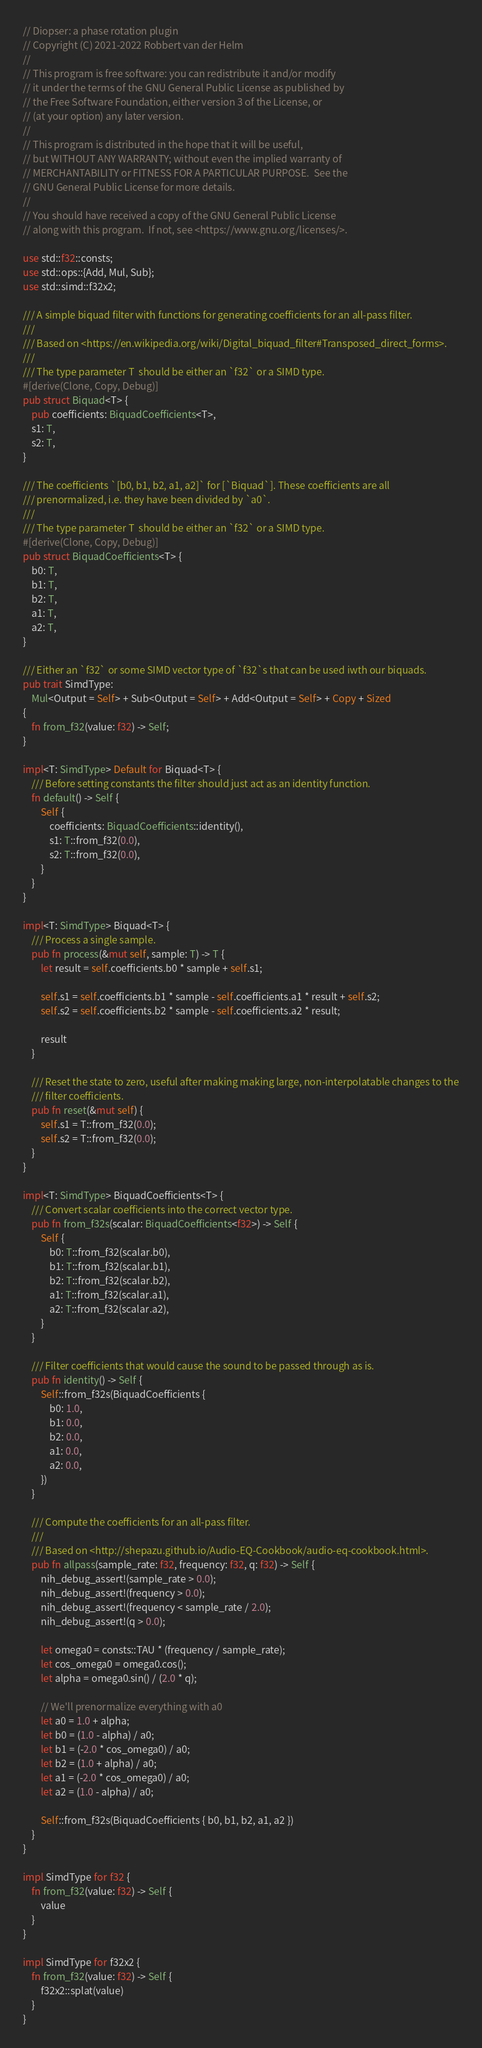<code> <loc_0><loc_0><loc_500><loc_500><_Rust_>// Diopser: a phase rotation plugin
// Copyright (C) 2021-2022 Robbert van der Helm
//
// This program is free software: you can redistribute it and/or modify
// it under the terms of the GNU General Public License as published by
// the Free Software Foundation, either version 3 of the License, or
// (at your option) any later version.
//
// This program is distributed in the hope that it will be useful,
// but WITHOUT ANY WARRANTY; without even the implied warranty of
// MERCHANTABILITY or FITNESS FOR A PARTICULAR PURPOSE.  See the
// GNU General Public License for more details.
//
// You should have received a copy of the GNU General Public License
// along with this program.  If not, see <https://www.gnu.org/licenses/>.

use std::f32::consts;
use std::ops::{Add, Mul, Sub};
use std::simd::f32x2;

/// A simple biquad filter with functions for generating coefficients for an all-pass filter.
///
/// Based on <https://en.wikipedia.org/wiki/Digital_biquad_filter#Transposed_direct_forms>.
///
/// The type parameter T  should be either an `f32` or a SIMD type.
#[derive(Clone, Copy, Debug)]
pub struct Biquad<T> {
    pub coefficients: BiquadCoefficients<T>,
    s1: T,
    s2: T,
}

/// The coefficients `[b0, b1, b2, a1, a2]` for [`Biquad`]. These coefficients are all
/// prenormalized, i.e. they have been divided by `a0`.
///
/// The type parameter T  should be either an `f32` or a SIMD type.
#[derive(Clone, Copy, Debug)]
pub struct BiquadCoefficients<T> {
    b0: T,
    b1: T,
    b2: T,
    a1: T,
    a2: T,
}

/// Either an `f32` or some SIMD vector type of `f32`s that can be used iwth our biquads.
pub trait SimdType:
    Mul<Output = Self> + Sub<Output = Self> + Add<Output = Self> + Copy + Sized
{
    fn from_f32(value: f32) -> Self;
}

impl<T: SimdType> Default for Biquad<T> {
    /// Before setting constants the filter should just act as an identity function.
    fn default() -> Self {
        Self {
            coefficients: BiquadCoefficients::identity(),
            s1: T::from_f32(0.0),
            s2: T::from_f32(0.0),
        }
    }
}

impl<T: SimdType> Biquad<T> {
    /// Process a single sample.
    pub fn process(&mut self, sample: T) -> T {
        let result = self.coefficients.b0 * sample + self.s1;

        self.s1 = self.coefficients.b1 * sample - self.coefficients.a1 * result + self.s2;
        self.s2 = self.coefficients.b2 * sample - self.coefficients.a2 * result;

        result
    }

    /// Reset the state to zero, useful after making making large, non-interpolatable changes to the
    /// filter coefficients.
    pub fn reset(&mut self) {
        self.s1 = T::from_f32(0.0);
        self.s2 = T::from_f32(0.0);
    }
}

impl<T: SimdType> BiquadCoefficients<T> {
    /// Convert scalar coefficients into the correct vector type.
    pub fn from_f32s(scalar: BiquadCoefficients<f32>) -> Self {
        Self {
            b0: T::from_f32(scalar.b0),
            b1: T::from_f32(scalar.b1),
            b2: T::from_f32(scalar.b2),
            a1: T::from_f32(scalar.a1),
            a2: T::from_f32(scalar.a2),
        }
    }

    /// Filter coefficients that would cause the sound to be passed through as is.
    pub fn identity() -> Self {
        Self::from_f32s(BiquadCoefficients {
            b0: 1.0,
            b1: 0.0,
            b2: 0.0,
            a1: 0.0,
            a2: 0.0,
        })
    }

    /// Compute the coefficients for an all-pass filter.
    ///
    /// Based on <http://shepazu.github.io/Audio-EQ-Cookbook/audio-eq-cookbook.html>.
    pub fn allpass(sample_rate: f32, frequency: f32, q: f32) -> Self {
        nih_debug_assert!(sample_rate > 0.0);
        nih_debug_assert!(frequency > 0.0);
        nih_debug_assert!(frequency < sample_rate / 2.0);
        nih_debug_assert!(q > 0.0);

        let omega0 = consts::TAU * (frequency / sample_rate);
        let cos_omega0 = omega0.cos();
        let alpha = omega0.sin() / (2.0 * q);

        // We'll prenormalize everything with a0
        let a0 = 1.0 + alpha;
        let b0 = (1.0 - alpha) / a0;
        let b1 = (-2.0 * cos_omega0) / a0;
        let b2 = (1.0 + alpha) / a0;
        let a1 = (-2.0 * cos_omega0) / a0;
        let a2 = (1.0 - alpha) / a0;

        Self::from_f32s(BiquadCoefficients { b0, b1, b2, a1, a2 })
    }
}

impl SimdType for f32 {
    fn from_f32(value: f32) -> Self {
        value
    }
}

impl SimdType for f32x2 {
    fn from_f32(value: f32) -> Self {
        f32x2::splat(value)
    }
}
</code> 